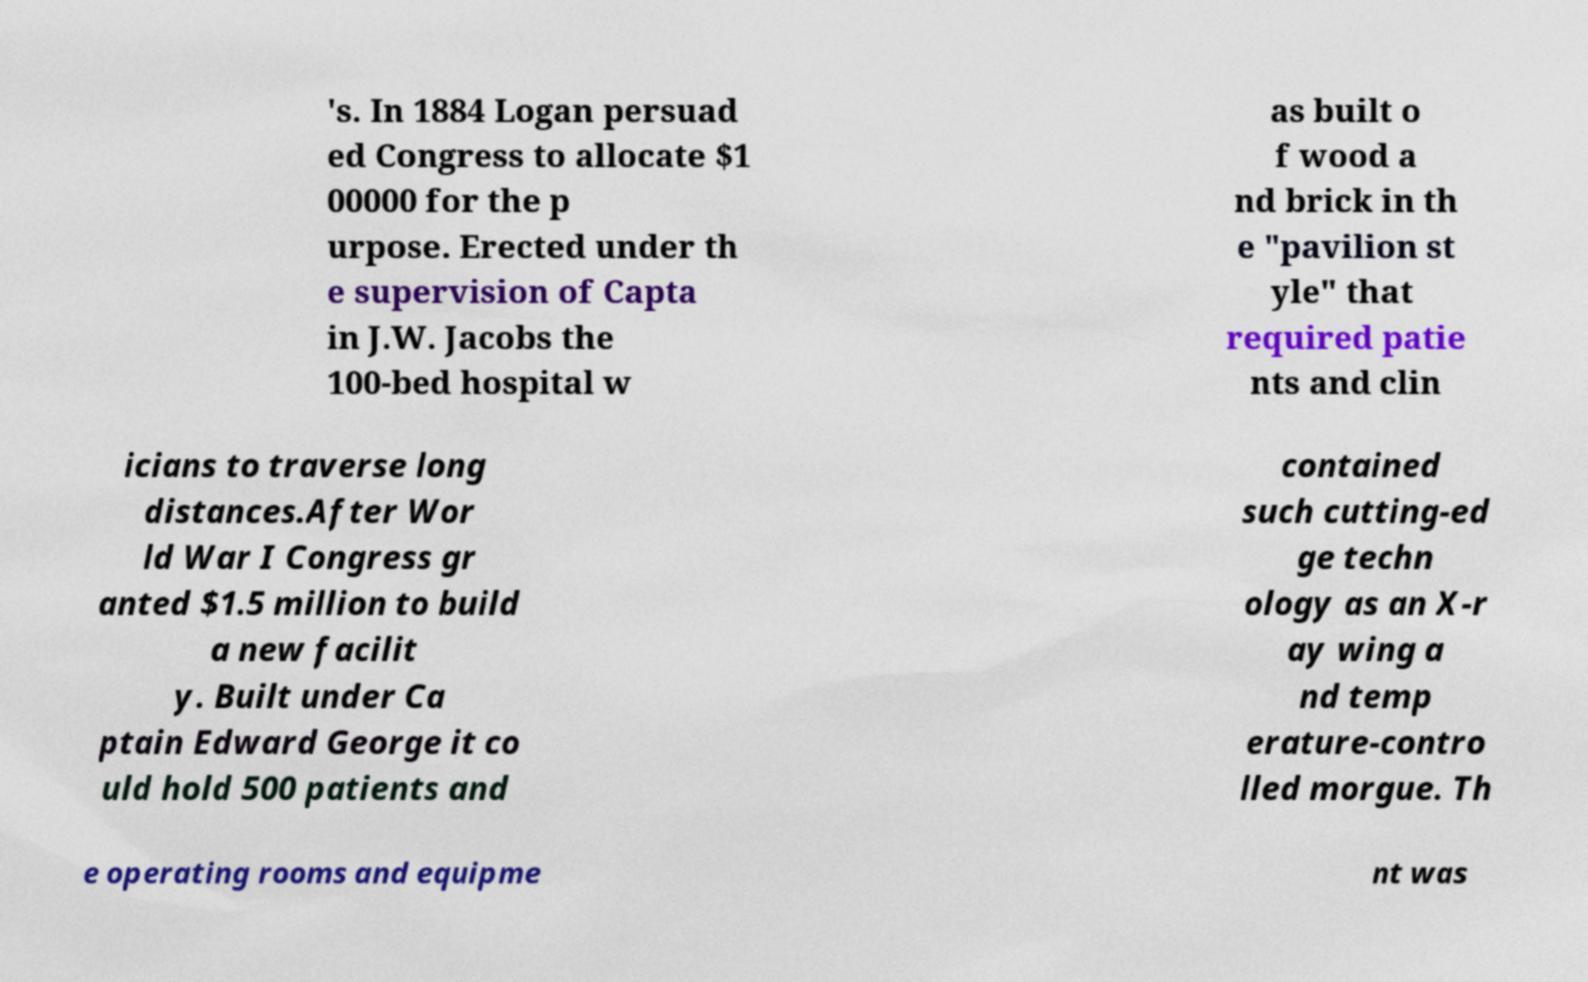There's text embedded in this image that I need extracted. Can you transcribe it verbatim? 's. In 1884 Logan persuad ed Congress to allocate $1 00000 for the p urpose. Erected under th e supervision of Capta in J.W. Jacobs the 100-bed hospital w as built o f wood a nd brick in th e "pavilion st yle" that required patie nts and clin icians to traverse long distances.After Wor ld War I Congress gr anted $1.5 million to build a new facilit y. Built under Ca ptain Edward George it co uld hold 500 patients and contained such cutting-ed ge techn ology as an X-r ay wing a nd temp erature-contro lled morgue. Th e operating rooms and equipme nt was 